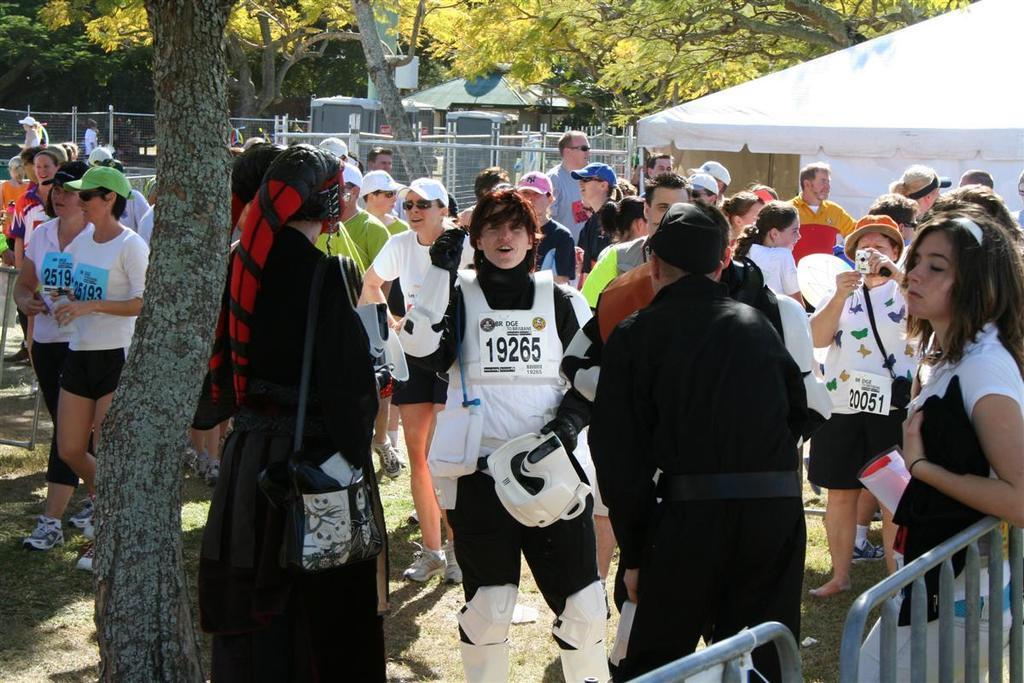In one or two sentences, can you explain what this image depicts? In this image I can see there are group of people visible in front of tent , tent is visible in the top right , at the top there are some trees , in the middle there is a fence, tent, at the bottom there is a fence , trunk of tree visible. 